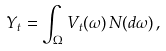<formula> <loc_0><loc_0><loc_500><loc_500>Y _ { t } = \int _ { \Omega } V _ { t } ( \omega ) \, N ( d \omega ) \, ,</formula> 